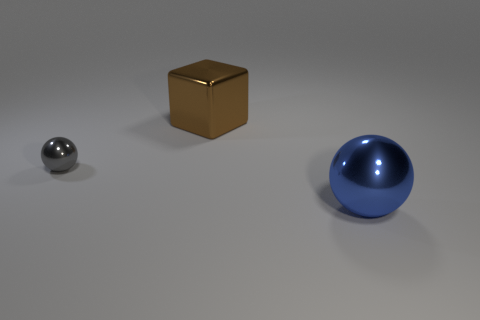Subtract all balls. How many objects are left? 1 Subtract 1 blocks. How many blocks are left? 0 Subtract all yellow cubes. Subtract all green spheres. How many cubes are left? 1 Subtract all purple cubes. How many gray spheres are left? 1 Subtract all shiny cubes. Subtract all gray metallic objects. How many objects are left? 1 Add 3 gray objects. How many gray objects are left? 4 Add 1 small metal things. How many small metal things exist? 2 Add 2 large purple cubes. How many objects exist? 5 Subtract all gray balls. How many balls are left? 1 Subtract 0 red spheres. How many objects are left? 3 